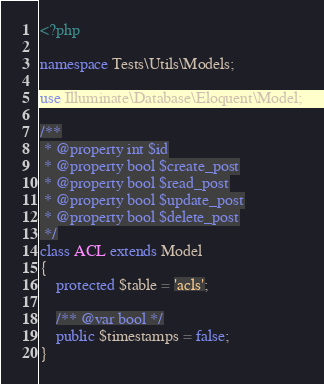Convert code to text. <code><loc_0><loc_0><loc_500><loc_500><_PHP_><?php

namespace Tests\Utils\Models;

use Illuminate\Database\Eloquent\Model;

/**
 * @property int $id
 * @property bool $create_post
 * @property bool $read_post
 * @property bool $update_post
 * @property bool $delete_post
 */
class ACL extends Model
{
    protected $table = 'acls';

    /** @var bool */
    public $timestamps = false;
}
</code> 